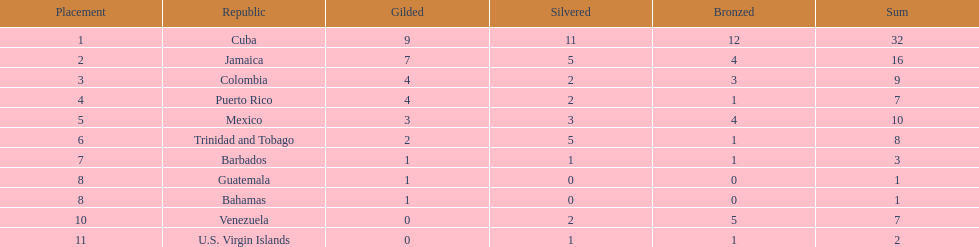Nations that had 10 or more medals each Cuba, Jamaica, Mexico. 